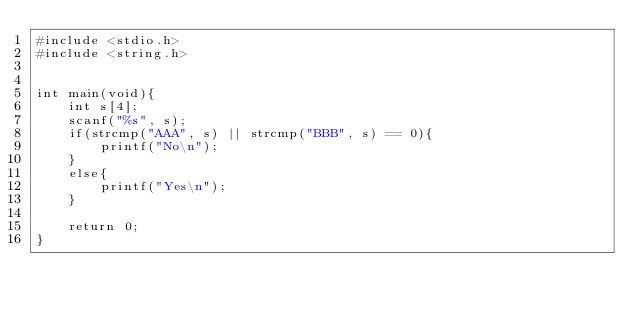<code> <loc_0><loc_0><loc_500><loc_500><_C_>#include <stdio.h>
#include <string.h>


int main(void){
    int s[4];
    scanf("%s", s);
    if(strcmp("AAA", s) || strcmp("BBB", s) == 0){
        printf("No\n");
    }
    else{
        printf("Yes\n");
    }

    return 0;
}</code> 